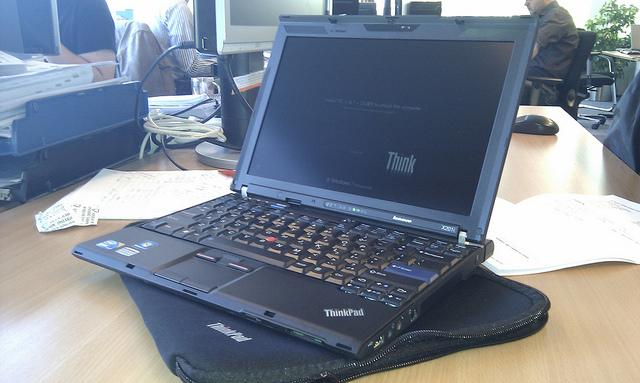What state is the computer most likely in? sleep 